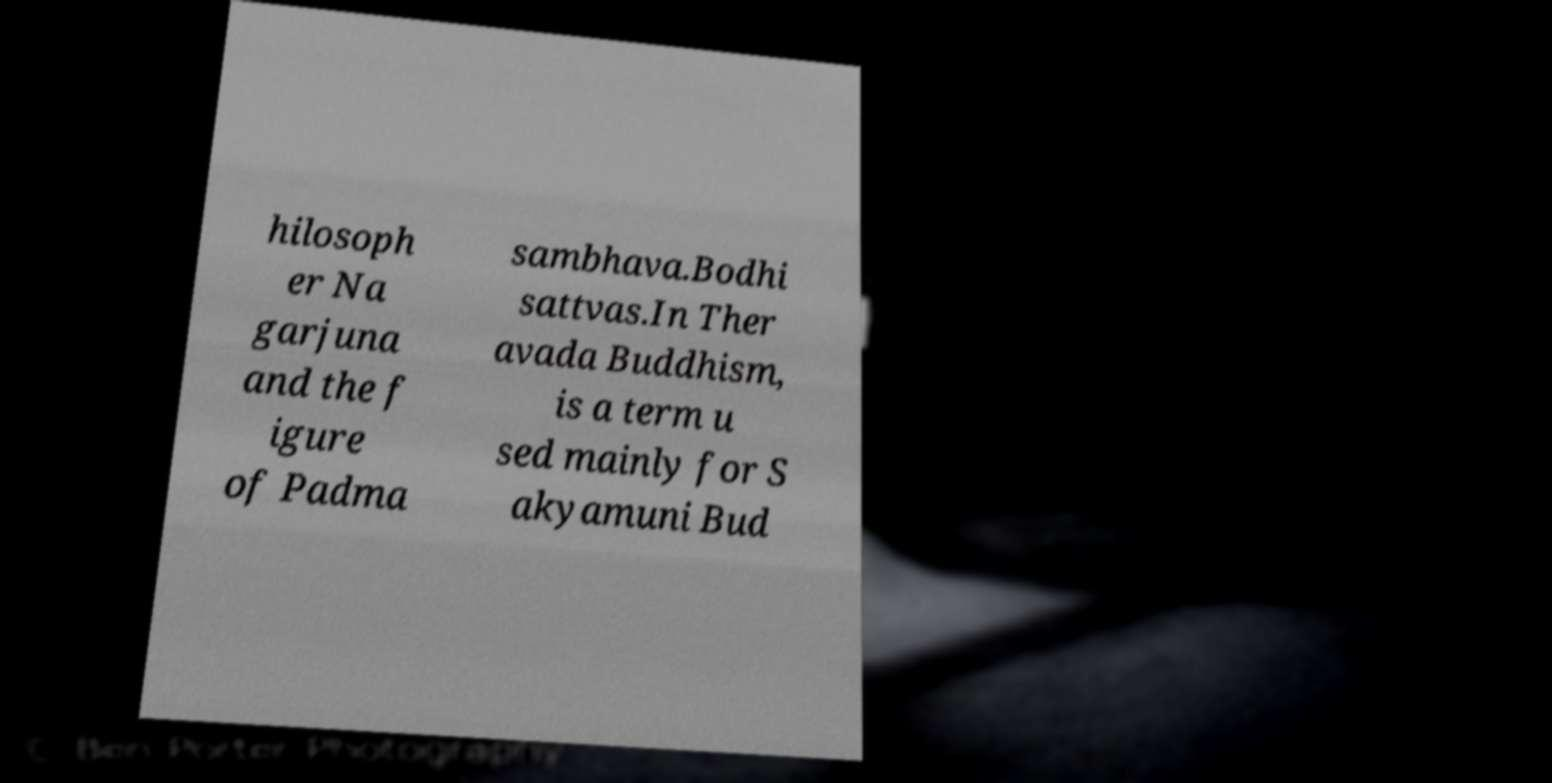For documentation purposes, I need the text within this image transcribed. Could you provide that? hilosoph er Na garjuna and the f igure of Padma sambhava.Bodhi sattvas.In Ther avada Buddhism, is a term u sed mainly for S akyamuni Bud 